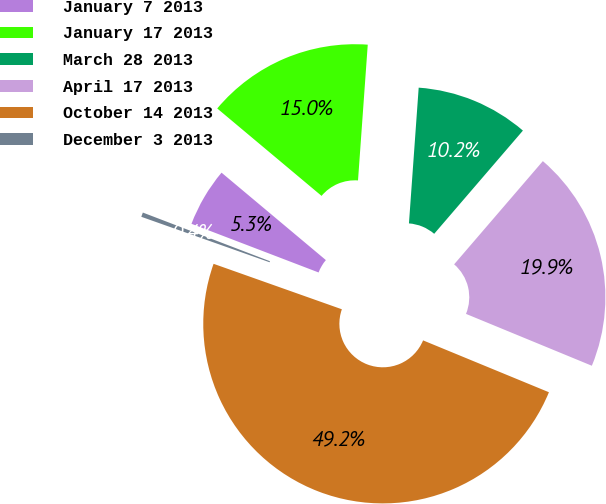Convert chart. <chart><loc_0><loc_0><loc_500><loc_500><pie_chart><fcel>January 7 2013<fcel>January 17 2013<fcel>March 28 2013<fcel>April 17 2013<fcel>October 14 2013<fcel>December 3 2013<nl><fcel>5.28%<fcel>15.04%<fcel>10.16%<fcel>19.92%<fcel>49.2%<fcel>0.4%<nl></chart> 